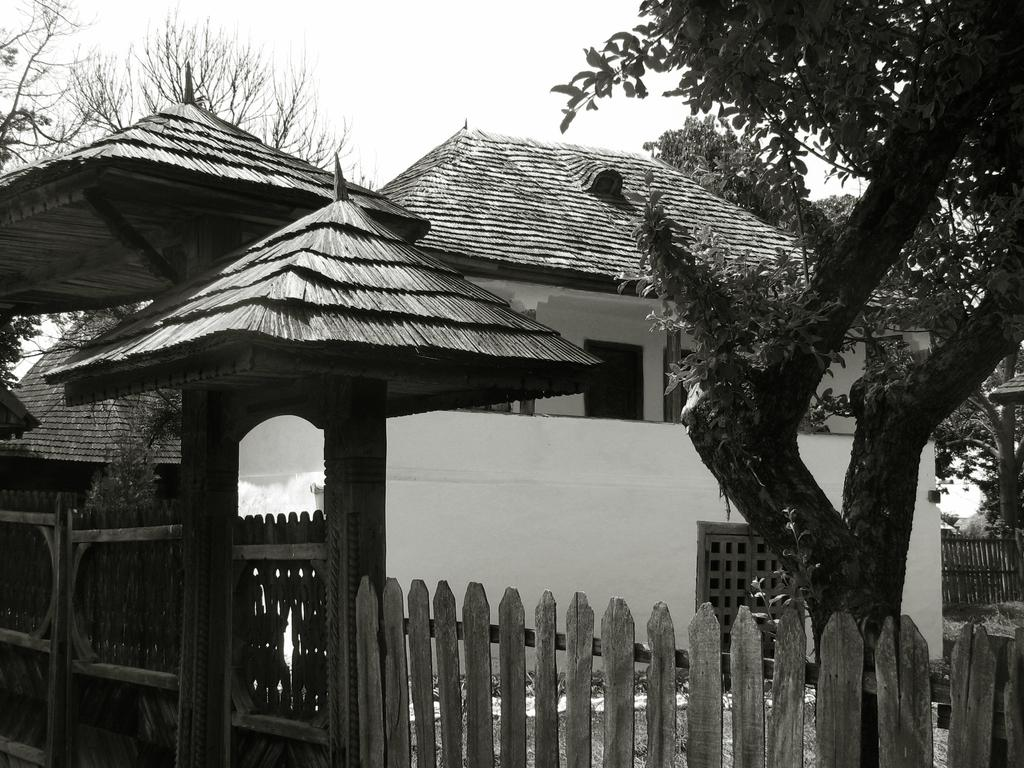What type of structures are visible in the image? There are houses in the image. What other natural elements can be seen in the image? There are trees in the image. What type of barrier is present in the image? There is a fence in the image. What is visible at the top of the image? The sky is visible at the top of the image. Where is the prison located in the image? There is no prison present in the image. What type of wood is used to construct the houses in the image? The provided facts do not mention the type of wood used to construct the houses, and therefore we cannot determine this information from the image. 